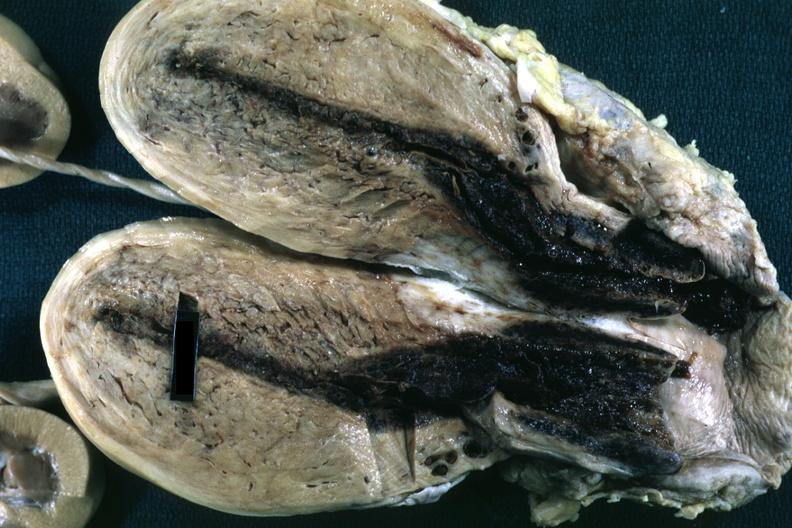does spina bifida show fixed tissue opened uterus with blood clot in cervical canal and small endometrial cavity?
Answer the question using a single word or phrase. No 